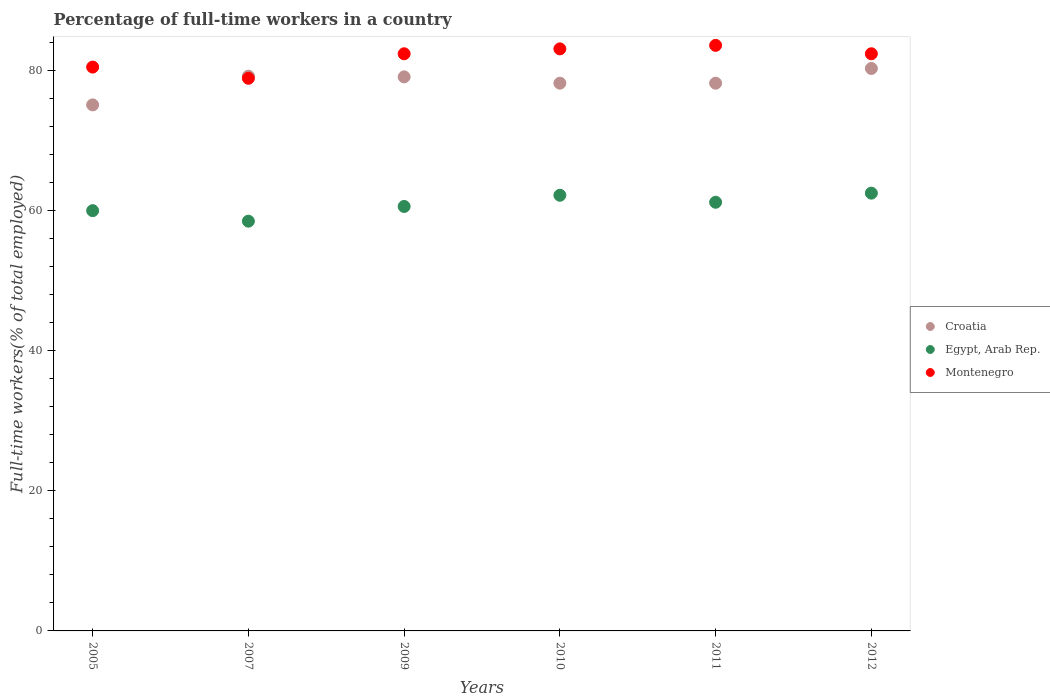Is the number of dotlines equal to the number of legend labels?
Ensure brevity in your answer.  Yes. What is the percentage of full-time workers in Egypt, Arab Rep. in 2009?
Provide a short and direct response. 60.6. Across all years, what is the maximum percentage of full-time workers in Egypt, Arab Rep.?
Offer a terse response. 62.5. Across all years, what is the minimum percentage of full-time workers in Croatia?
Keep it short and to the point. 75.1. In which year was the percentage of full-time workers in Egypt, Arab Rep. minimum?
Offer a terse response. 2007. What is the total percentage of full-time workers in Croatia in the graph?
Your answer should be very brief. 470.1. What is the difference between the percentage of full-time workers in Egypt, Arab Rep. in 2009 and that in 2012?
Your answer should be compact. -1.9. What is the difference between the percentage of full-time workers in Egypt, Arab Rep. in 2005 and the percentage of full-time workers in Croatia in 2012?
Your answer should be compact. -20.3. What is the average percentage of full-time workers in Montenegro per year?
Provide a succinct answer. 81.82. In the year 2011, what is the difference between the percentage of full-time workers in Croatia and percentage of full-time workers in Egypt, Arab Rep.?
Your response must be concise. 17. In how many years, is the percentage of full-time workers in Montenegro greater than 8 %?
Provide a short and direct response. 6. What is the ratio of the percentage of full-time workers in Croatia in 2007 to that in 2011?
Give a very brief answer. 1.01. Is the difference between the percentage of full-time workers in Croatia in 2011 and 2012 greater than the difference between the percentage of full-time workers in Egypt, Arab Rep. in 2011 and 2012?
Your answer should be very brief. No. What is the difference between the highest and the lowest percentage of full-time workers in Croatia?
Provide a short and direct response. 5.2. In how many years, is the percentage of full-time workers in Croatia greater than the average percentage of full-time workers in Croatia taken over all years?
Make the answer very short. 3. Is the sum of the percentage of full-time workers in Egypt, Arab Rep. in 2007 and 2011 greater than the maximum percentage of full-time workers in Montenegro across all years?
Offer a very short reply. Yes. Is it the case that in every year, the sum of the percentage of full-time workers in Egypt, Arab Rep. and percentage of full-time workers in Croatia  is greater than the percentage of full-time workers in Montenegro?
Keep it short and to the point. Yes. Is the percentage of full-time workers in Montenegro strictly greater than the percentage of full-time workers in Croatia over the years?
Keep it short and to the point. No. How many dotlines are there?
Give a very brief answer. 3. Are the values on the major ticks of Y-axis written in scientific E-notation?
Provide a succinct answer. No. Does the graph contain any zero values?
Give a very brief answer. No. Does the graph contain grids?
Your response must be concise. No. How many legend labels are there?
Your answer should be compact. 3. What is the title of the graph?
Your answer should be very brief. Percentage of full-time workers in a country. What is the label or title of the X-axis?
Give a very brief answer. Years. What is the label or title of the Y-axis?
Give a very brief answer. Full-time workers(% of total employed). What is the Full-time workers(% of total employed) of Croatia in 2005?
Give a very brief answer. 75.1. What is the Full-time workers(% of total employed) of Egypt, Arab Rep. in 2005?
Your answer should be very brief. 60. What is the Full-time workers(% of total employed) of Montenegro in 2005?
Keep it short and to the point. 80.5. What is the Full-time workers(% of total employed) of Croatia in 2007?
Make the answer very short. 79.2. What is the Full-time workers(% of total employed) in Egypt, Arab Rep. in 2007?
Keep it short and to the point. 58.5. What is the Full-time workers(% of total employed) in Montenegro in 2007?
Your response must be concise. 78.9. What is the Full-time workers(% of total employed) of Croatia in 2009?
Your answer should be very brief. 79.1. What is the Full-time workers(% of total employed) of Egypt, Arab Rep. in 2009?
Provide a short and direct response. 60.6. What is the Full-time workers(% of total employed) of Montenegro in 2009?
Provide a succinct answer. 82.4. What is the Full-time workers(% of total employed) of Croatia in 2010?
Give a very brief answer. 78.2. What is the Full-time workers(% of total employed) of Egypt, Arab Rep. in 2010?
Your answer should be very brief. 62.2. What is the Full-time workers(% of total employed) in Montenegro in 2010?
Offer a terse response. 83.1. What is the Full-time workers(% of total employed) in Croatia in 2011?
Make the answer very short. 78.2. What is the Full-time workers(% of total employed) in Egypt, Arab Rep. in 2011?
Offer a very short reply. 61.2. What is the Full-time workers(% of total employed) in Montenegro in 2011?
Keep it short and to the point. 83.6. What is the Full-time workers(% of total employed) of Croatia in 2012?
Give a very brief answer. 80.3. What is the Full-time workers(% of total employed) of Egypt, Arab Rep. in 2012?
Keep it short and to the point. 62.5. What is the Full-time workers(% of total employed) of Montenegro in 2012?
Offer a terse response. 82.4. Across all years, what is the maximum Full-time workers(% of total employed) of Croatia?
Offer a terse response. 80.3. Across all years, what is the maximum Full-time workers(% of total employed) of Egypt, Arab Rep.?
Keep it short and to the point. 62.5. Across all years, what is the maximum Full-time workers(% of total employed) of Montenegro?
Ensure brevity in your answer.  83.6. Across all years, what is the minimum Full-time workers(% of total employed) in Croatia?
Your response must be concise. 75.1. Across all years, what is the minimum Full-time workers(% of total employed) of Egypt, Arab Rep.?
Your answer should be very brief. 58.5. Across all years, what is the minimum Full-time workers(% of total employed) in Montenegro?
Ensure brevity in your answer.  78.9. What is the total Full-time workers(% of total employed) in Croatia in the graph?
Your answer should be very brief. 470.1. What is the total Full-time workers(% of total employed) in Egypt, Arab Rep. in the graph?
Ensure brevity in your answer.  365. What is the total Full-time workers(% of total employed) in Montenegro in the graph?
Offer a very short reply. 490.9. What is the difference between the Full-time workers(% of total employed) in Croatia in 2005 and that in 2007?
Offer a very short reply. -4.1. What is the difference between the Full-time workers(% of total employed) in Egypt, Arab Rep. in 2005 and that in 2009?
Give a very brief answer. -0.6. What is the difference between the Full-time workers(% of total employed) in Montenegro in 2005 and that in 2009?
Make the answer very short. -1.9. What is the difference between the Full-time workers(% of total employed) in Egypt, Arab Rep. in 2005 and that in 2010?
Your answer should be very brief. -2.2. What is the difference between the Full-time workers(% of total employed) of Croatia in 2005 and that in 2011?
Offer a terse response. -3.1. What is the difference between the Full-time workers(% of total employed) in Montenegro in 2005 and that in 2011?
Provide a short and direct response. -3.1. What is the difference between the Full-time workers(% of total employed) in Egypt, Arab Rep. in 2007 and that in 2010?
Your answer should be compact. -3.7. What is the difference between the Full-time workers(% of total employed) in Montenegro in 2007 and that in 2011?
Your answer should be very brief. -4.7. What is the difference between the Full-time workers(% of total employed) of Croatia in 2007 and that in 2012?
Your answer should be compact. -1.1. What is the difference between the Full-time workers(% of total employed) in Egypt, Arab Rep. in 2007 and that in 2012?
Offer a terse response. -4. What is the difference between the Full-time workers(% of total employed) in Croatia in 2009 and that in 2010?
Your response must be concise. 0.9. What is the difference between the Full-time workers(% of total employed) in Egypt, Arab Rep. in 2009 and that in 2011?
Your answer should be compact. -0.6. What is the difference between the Full-time workers(% of total employed) of Montenegro in 2009 and that in 2011?
Your response must be concise. -1.2. What is the difference between the Full-time workers(% of total employed) in Egypt, Arab Rep. in 2009 and that in 2012?
Offer a very short reply. -1.9. What is the difference between the Full-time workers(% of total employed) of Montenegro in 2009 and that in 2012?
Give a very brief answer. 0. What is the difference between the Full-time workers(% of total employed) of Croatia in 2010 and that in 2012?
Your answer should be compact. -2.1. What is the difference between the Full-time workers(% of total employed) in Montenegro in 2010 and that in 2012?
Keep it short and to the point. 0.7. What is the difference between the Full-time workers(% of total employed) in Croatia in 2011 and that in 2012?
Make the answer very short. -2.1. What is the difference between the Full-time workers(% of total employed) in Croatia in 2005 and the Full-time workers(% of total employed) in Egypt, Arab Rep. in 2007?
Offer a terse response. 16.6. What is the difference between the Full-time workers(% of total employed) in Egypt, Arab Rep. in 2005 and the Full-time workers(% of total employed) in Montenegro in 2007?
Give a very brief answer. -18.9. What is the difference between the Full-time workers(% of total employed) of Egypt, Arab Rep. in 2005 and the Full-time workers(% of total employed) of Montenegro in 2009?
Offer a very short reply. -22.4. What is the difference between the Full-time workers(% of total employed) of Egypt, Arab Rep. in 2005 and the Full-time workers(% of total employed) of Montenegro in 2010?
Offer a very short reply. -23.1. What is the difference between the Full-time workers(% of total employed) in Croatia in 2005 and the Full-time workers(% of total employed) in Egypt, Arab Rep. in 2011?
Your answer should be very brief. 13.9. What is the difference between the Full-time workers(% of total employed) of Croatia in 2005 and the Full-time workers(% of total employed) of Montenegro in 2011?
Your response must be concise. -8.5. What is the difference between the Full-time workers(% of total employed) of Egypt, Arab Rep. in 2005 and the Full-time workers(% of total employed) of Montenegro in 2011?
Make the answer very short. -23.6. What is the difference between the Full-time workers(% of total employed) in Croatia in 2005 and the Full-time workers(% of total employed) in Egypt, Arab Rep. in 2012?
Provide a succinct answer. 12.6. What is the difference between the Full-time workers(% of total employed) in Egypt, Arab Rep. in 2005 and the Full-time workers(% of total employed) in Montenegro in 2012?
Make the answer very short. -22.4. What is the difference between the Full-time workers(% of total employed) in Croatia in 2007 and the Full-time workers(% of total employed) in Egypt, Arab Rep. in 2009?
Your response must be concise. 18.6. What is the difference between the Full-time workers(% of total employed) of Egypt, Arab Rep. in 2007 and the Full-time workers(% of total employed) of Montenegro in 2009?
Keep it short and to the point. -23.9. What is the difference between the Full-time workers(% of total employed) in Croatia in 2007 and the Full-time workers(% of total employed) in Montenegro in 2010?
Your answer should be compact. -3.9. What is the difference between the Full-time workers(% of total employed) of Egypt, Arab Rep. in 2007 and the Full-time workers(% of total employed) of Montenegro in 2010?
Give a very brief answer. -24.6. What is the difference between the Full-time workers(% of total employed) of Egypt, Arab Rep. in 2007 and the Full-time workers(% of total employed) of Montenegro in 2011?
Keep it short and to the point. -25.1. What is the difference between the Full-time workers(% of total employed) in Croatia in 2007 and the Full-time workers(% of total employed) in Montenegro in 2012?
Provide a succinct answer. -3.2. What is the difference between the Full-time workers(% of total employed) in Egypt, Arab Rep. in 2007 and the Full-time workers(% of total employed) in Montenegro in 2012?
Make the answer very short. -23.9. What is the difference between the Full-time workers(% of total employed) of Egypt, Arab Rep. in 2009 and the Full-time workers(% of total employed) of Montenegro in 2010?
Give a very brief answer. -22.5. What is the difference between the Full-time workers(% of total employed) in Croatia in 2009 and the Full-time workers(% of total employed) in Egypt, Arab Rep. in 2011?
Provide a short and direct response. 17.9. What is the difference between the Full-time workers(% of total employed) of Croatia in 2009 and the Full-time workers(% of total employed) of Egypt, Arab Rep. in 2012?
Make the answer very short. 16.6. What is the difference between the Full-time workers(% of total employed) of Croatia in 2009 and the Full-time workers(% of total employed) of Montenegro in 2012?
Ensure brevity in your answer.  -3.3. What is the difference between the Full-time workers(% of total employed) of Egypt, Arab Rep. in 2009 and the Full-time workers(% of total employed) of Montenegro in 2012?
Provide a succinct answer. -21.8. What is the difference between the Full-time workers(% of total employed) of Croatia in 2010 and the Full-time workers(% of total employed) of Montenegro in 2011?
Your response must be concise. -5.4. What is the difference between the Full-time workers(% of total employed) of Egypt, Arab Rep. in 2010 and the Full-time workers(% of total employed) of Montenegro in 2011?
Offer a terse response. -21.4. What is the difference between the Full-time workers(% of total employed) of Egypt, Arab Rep. in 2010 and the Full-time workers(% of total employed) of Montenegro in 2012?
Provide a succinct answer. -20.2. What is the difference between the Full-time workers(% of total employed) of Croatia in 2011 and the Full-time workers(% of total employed) of Egypt, Arab Rep. in 2012?
Your answer should be very brief. 15.7. What is the difference between the Full-time workers(% of total employed) in Egypt, Arab Rep. in 2011 and the Full-time workers(% of total employed) in Montenegro in 2012?
Your answer should be compact. -21.2. What is the average Full-time workers(% of total employed) of Croatia per year?
Your answer should be compact. 78.35. What is the average Full-time workers(% of total employed) in Egypt, Arab Rep. per year?
Your answer should be compact. 60.83. What is the average Full-time workers(% of total employed) in Montenegro per year?
Your answer should be compact. 81.82. In the year 2005, what is the difference between the Full-time workers(% of total employed) in Croatia and Full-time workers(% of total employed) in Montenegro?
Make the answer very short. -5.4. In the year 2005, what is the difference between the Full-time workers(% of total employed) of Egypt, Arab Rep. and Full-time workers(% of total employed) of Montenegro?
Offer a very short reply. -20.5. In the year 2007, what is the difference between the Full-time workers(% of total employed) of Croatia and Full-time workers(% of total employed) of Egypt, Arab Rep.?
Give a very brief answer. 20.7. In the year 2007, what is the difference between the Full-time workers(% of total employed) in Egypt, Arab Rep. and Full-time workers(% of total employed) in Montenegro?
Offer a terse response. -20.4. In the year 2009, what is the difference between the Full-time workers(% of total employed) in Egypt, Arab Rep. and Full-time workers(% of total employed) in Montenegro?
Ensure brevity in your answer.  -21.8. In the year 2010, what is the difference between the Full-time workers(% of total employed) of Croatia and Full-time workers(% of total employed) of Montenegro?
Ensure brevity in your answer.  -4.9. In the year 2010, what is the difference between the Full-time workers(% of total employed) in Egypt, Arab Rep. and Full-time workers(% of total employed) in Montenegro?
Your answer should be very brief. -20.9. In the year 2011, what is the difference between the Full-time workers(% of total employed) of Egypt, Arab Rep. and Full-time workers(% of total employed) of Montenegro?
Your answer should be very brief. -22.4. In the year 2012, what is the difference between the Full-time workers(% of total employed) of Croatia and Full-time workers(% of total employed) of Montenegro?
Your response must be concise. -2.1. In the year 2012, what is the difference between the Full-time workers(% of total employed) of Egypt, Arab Rep. and Full-time workers(% of total employed) of Montenegro?
Make the answer very short. -19.9. What is the ratio of the Full-time workers(% of total employed) in Croatia in 2005 to that in 2007?
Your response must be concise. 0.95. What is the ratio of the Full-time workers(% of total employed) in Egypt, Arab Rep. in 2005 to that in 2007?
Give a very brief answer. 1.03. What is the ratio of the Full-time workers(% of total employed) in Montenegro in 2005 to that in 2007?
Make the answer very short. 1.02. What is the ratio of the Full-time workers(% of total employed) in Croatia in 2005 to that in 2009?
Provide a succinct answer. 0.95. What is the ratio of the Full-time workers(% of total employed) in Montenegro in 2005 to that in 2009?
Keep it short and to the point. 0.98. What is the ratio of the Full-time workers(% of total employed) of Croatia in 2005 to that in 2010?
Offer a terse response. 0.96. What is the ratio of the Full-time workers(% of total employed) of Egypt, Arab Rep. in 2005 to that in 2010?
Make the answer very short. 0.96. What is the ratio of the Full-time workers(% of total employed) in Montenegro in 2005 to that in 2010?
Provide a short and direct response. 0.97. What is the ratio of the Full-time workers(% of total employed) of Croatia in 2005 to that in 2011?
Give a very brief answer. 0.96. What is the ratio of the Full-time workers(% of total employed) of Egypt, Arab Rep. in 2005 to that in 2011?
Keep it short and to the point. 0.98. What is the ratio of the Full-time workers(% of total employed) in Montenegro in 2005 to that in 2011?
Your answer should be compact. 0.96. What is the ratio of the Full-time workers(% of total employed) in Croatia in 2005 to that in 2012?
Offer a terse response. 0.94. What is the ratio of the Full-time workers(% of total employed) in Montenegro in 2005 to that in 2012?
Your answer should be very brief. 0.98. What is the ratio of the Full-time workers(% of total employed) in Egypt, Arab Rep. in 2007 to that in 2009?
Ensure brevity in your answer.  0.97. What is the ratio of the Full-time workers(% of total employed) in Montenegro in 2007 to that in 2009?
Make the answer very short. 0.96. What is the ratio of the Full-time workers(% of total employed) of Croatia in 2007 to that in 2010?
Your answer should be very brief. 1.01. What is the ratio of the Full-time workers(% of total employed) in Egypt, Arab Rep. in 2007 to that in 2010?
Your answer should be compact. 0.94. What is the ratio of the Full-time workers(% of total employed) in Montenegro in 2007 to that in 2010?
Offer a terse response. 0.95. What is the ratio of the Full-time workers(% of total employed) of Croatia in 2007 to that in 2011?
Give a very brief answer. 1.01. What is the ratio of the Full-time workers(% of total employed) of Egypt, Arab Rep. in 2007 to that in 2011?
Provide a succinct answer. 0.96. What is the ratio of the Full-time workers(% of total employed) of Montenegro in 2007 to that in 2011?
Make the answer very short. 0.94. What is the ratio of the Full-time workers(% of total employed) of Croatia in 2007 to that in 2012?
Give a very brief answer. 0.99. What is the ratio of the Full-time workers(% of total employed) in Egypt, Arab Rep. in 2007 to that in 2012?
Give a very brief answer. 0.94. What is the ratio of the Full-time workers(% of total employed) of Montenegro in 2007 to that in 2012?
Your answer should be compact. 0.96. What is the ratio of the Full-time workers(% of total employed) of Croatia in 2009 to that in 2010?
Make the answer very short. 1.01. What is the ratio of the Full-time workers(% of total employed) in Egypt, Arab Rep. in 2009 to that in 2010?
Your answer should be compact. 0.97. What is the ratio of the Full-time workers(% of total employed) in Montenegro in 2009 to that in 2010?
Offer a very short reply. 0.99. What is the ratio of the Full-time workers(% of total employed) in Croatia in 2009 to that in 2011?
Offer a very short reply. 1.01. What is the ratio of the Full-time workers(% of total employed) of Egypt, Arab Rep. in 2009 to that in 2011?
Provide a succinct answer. 0.99. What is the ratio of the Full-time workers(% of total employed) in Montenegro in 2009 to that in 2011?
Your answer should be compact. 0.99. What is the ratio of the Full-time workers(% of total employed) in Croatia in 2009 to that in 2012?
Provide a succinct answer. 0.99. What is the ratio of the Full-time workers(% of total employed) in Egypt, Arab Rep. in 2009 to that in 2012?
Offer a very short reply. 0.97. What is the ratio of the Full-time workers(% of total employed) of Montenegro in 2009 to that in 2012?
Give a very brief answer. 1. What is the ratio of the Full-time workers(% of total employed) in Egypt, Arab Rep. in 2010 to that in 2011?
Your answer should be very brief. 1.02. What is the ratio of the Full-time workers(% of total employed) in Montenegro in 2010 to that in 2011?
Your answer should be compact. 0.99. What is the ratio of the Full-time workers(% of total employed) in Croatia in 2010 to that in 2012?
Keep it short and to the point. 0.97. What is the ratio of the Full-time workers(% of total employed) in Egypt, Arab Rep. in 2010 to that in 2012?
Keep it short and to the point. 1. What is the ratio of the Full-time workers(% of total employed) of Montenegro in 2010 to that in 2012?
Keep it short and to the point. 1.01. What is the ratio of the Full-time workers(% of total employed) of Croatia in 2011 to that in 2012?
Your response must be concise. 0.97. What is the ratio of the Full-time workers(% of total employed) of Egypt, Arab Rep. in 2011 to that in 2012?
Ensure brevity in your answer.  0.98. What is the ratio of the Full-time workers(% of total employed) of Montenegro in 2011 to that in 2012?
Your answer should be compact. 1.01. What is the difference between the highest and the second highest Full-time workers(% of total employed) in Egypt, Arab Rep.?
Ensure brevity in your answer.  0.3. What is the difference between the highest and the second highest Full-time workers(% of total employed) in Montenegro?
Provide a short and direct response. 0.5. What is the difference between the highest and the lowest Full-time workers(% of total employed) of Egypt, Arab Rep.?
Keep it short and to the point. 4. 